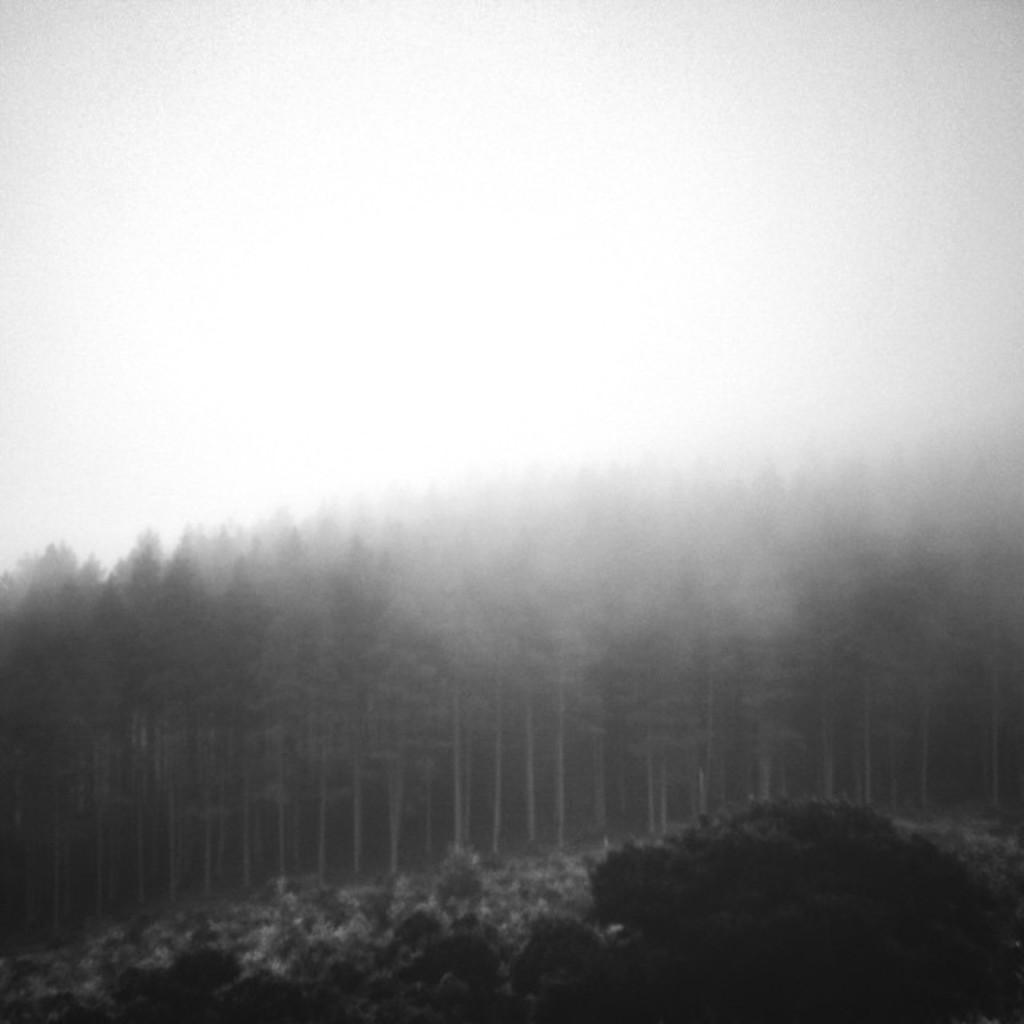What is the color scheme of the image? The image is black and white. What type of natural elements can be seen in the picture? There are many tall trees in the picture. Can you see a glove hanging from one of the trees in the image? There is no glove present in the image; it features tall trees in a black and white color scheme. 